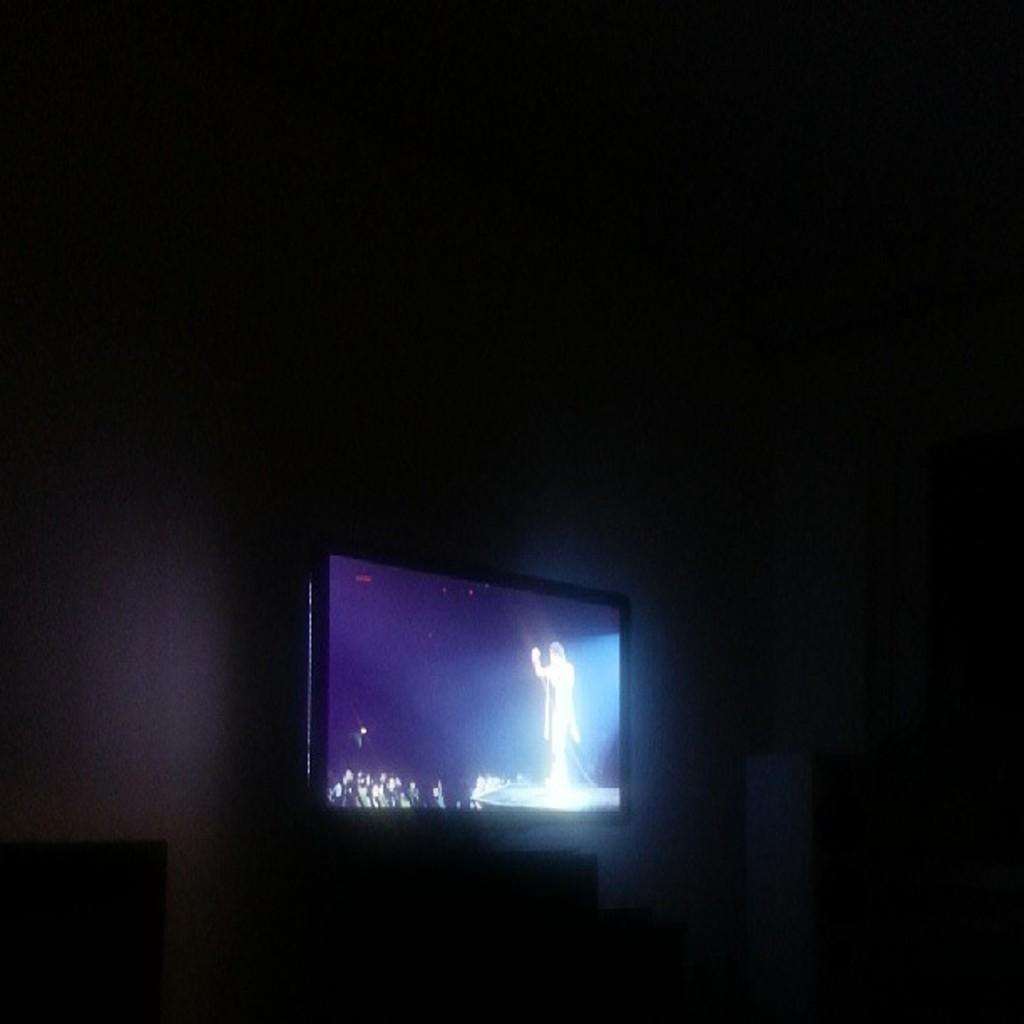What electronic device is present in the image? There is a television in the image. Where is the television located? The television is placed on a table. What can be seen behind the television? There is a wall visible in the image. What type of songs can be heard coming from the owl in the image? There is no owl present in the image, so it is not possible to determine what, if any, songs might be heard. 